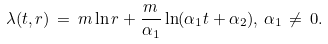<formula> <loc_0><loc_0><loc_500><loc_500>\lambda ( t , r ) \, = \, m \ln r + \frac { m } { { { \alpha } _ { 1 } } } \ln ( { { \alpha } _ { 1 } } t + { { \alpha } _ { 2 } } ) , \, { { \alpha } _ { 1 } } \, \neq \, 0 .</formula> 